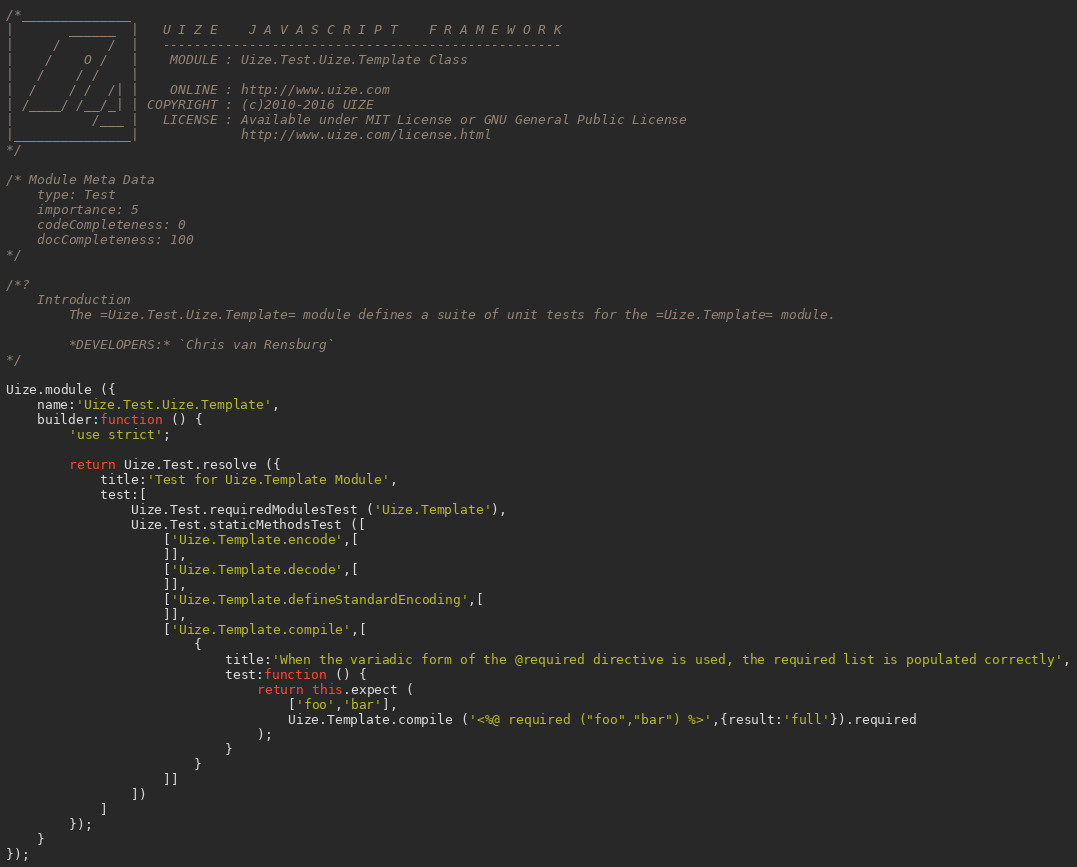<code> <loc_0><loc_0><loc_500><loc_500><_JavaScript_>/*______________
|       ______  |   U I Z E    J A V A S C R I P T    F R A M E W O R K
|     /      /  |   ---------------------------------------------------
|    /    O /   |    MODULE : Uize.Test.Uize.Template Class
|   /    / /    |
|  /    / /  /| |    ONLINE : http://www.uize.com
| /____/ /__/_| | COPYRIGHT : (c)2010-2016 UIZE
|          /___ |   LICENSE : Available under MIT License or GNU General Public License
|_______________|             http://www.uize.com/license.html
*/

/* Module Meta Data
	type: Test
	importance: 5
	codeCompleteness: 0
	docCompleteness: 100
*/

/*?
	Introduction
		The =Uize.Test.Uize.Template= module defines a suite of unit tests for the =Uize.Template= module.

		*DEVELOPERS:* `Chris van Rensburg`
*/

Uize.module ({
	name:'Uize.Test.Uize.Template',
	builder:function () {
		'use strict';

		return Uize.Test.resolve ({
			title:'Test for Uize.Template Module',
			test:[
				Uize.Test.requiredModulesTest ('Uize.Template'),
				Uize.Test.staticMethodsTest ([
					['Uize.Template.encode',[
					]],
					['Uize.Template.decode',[
					]],
					['Uize.Template.defineStandardEncoding',[
					]],
					['Uize.Template.compile',[
						{
							title:'When the variadic form of the @required directive is used, the required list is populated correctly',
							test:function () {
								return this.expect (
									['foo','bar'],
									Uize.Template.compile ('<%@ required ("foo","bar") %>',{result:'full'}).required
								);
							}
						}
					]]
				])
			]
		});
	}
});

</code> 